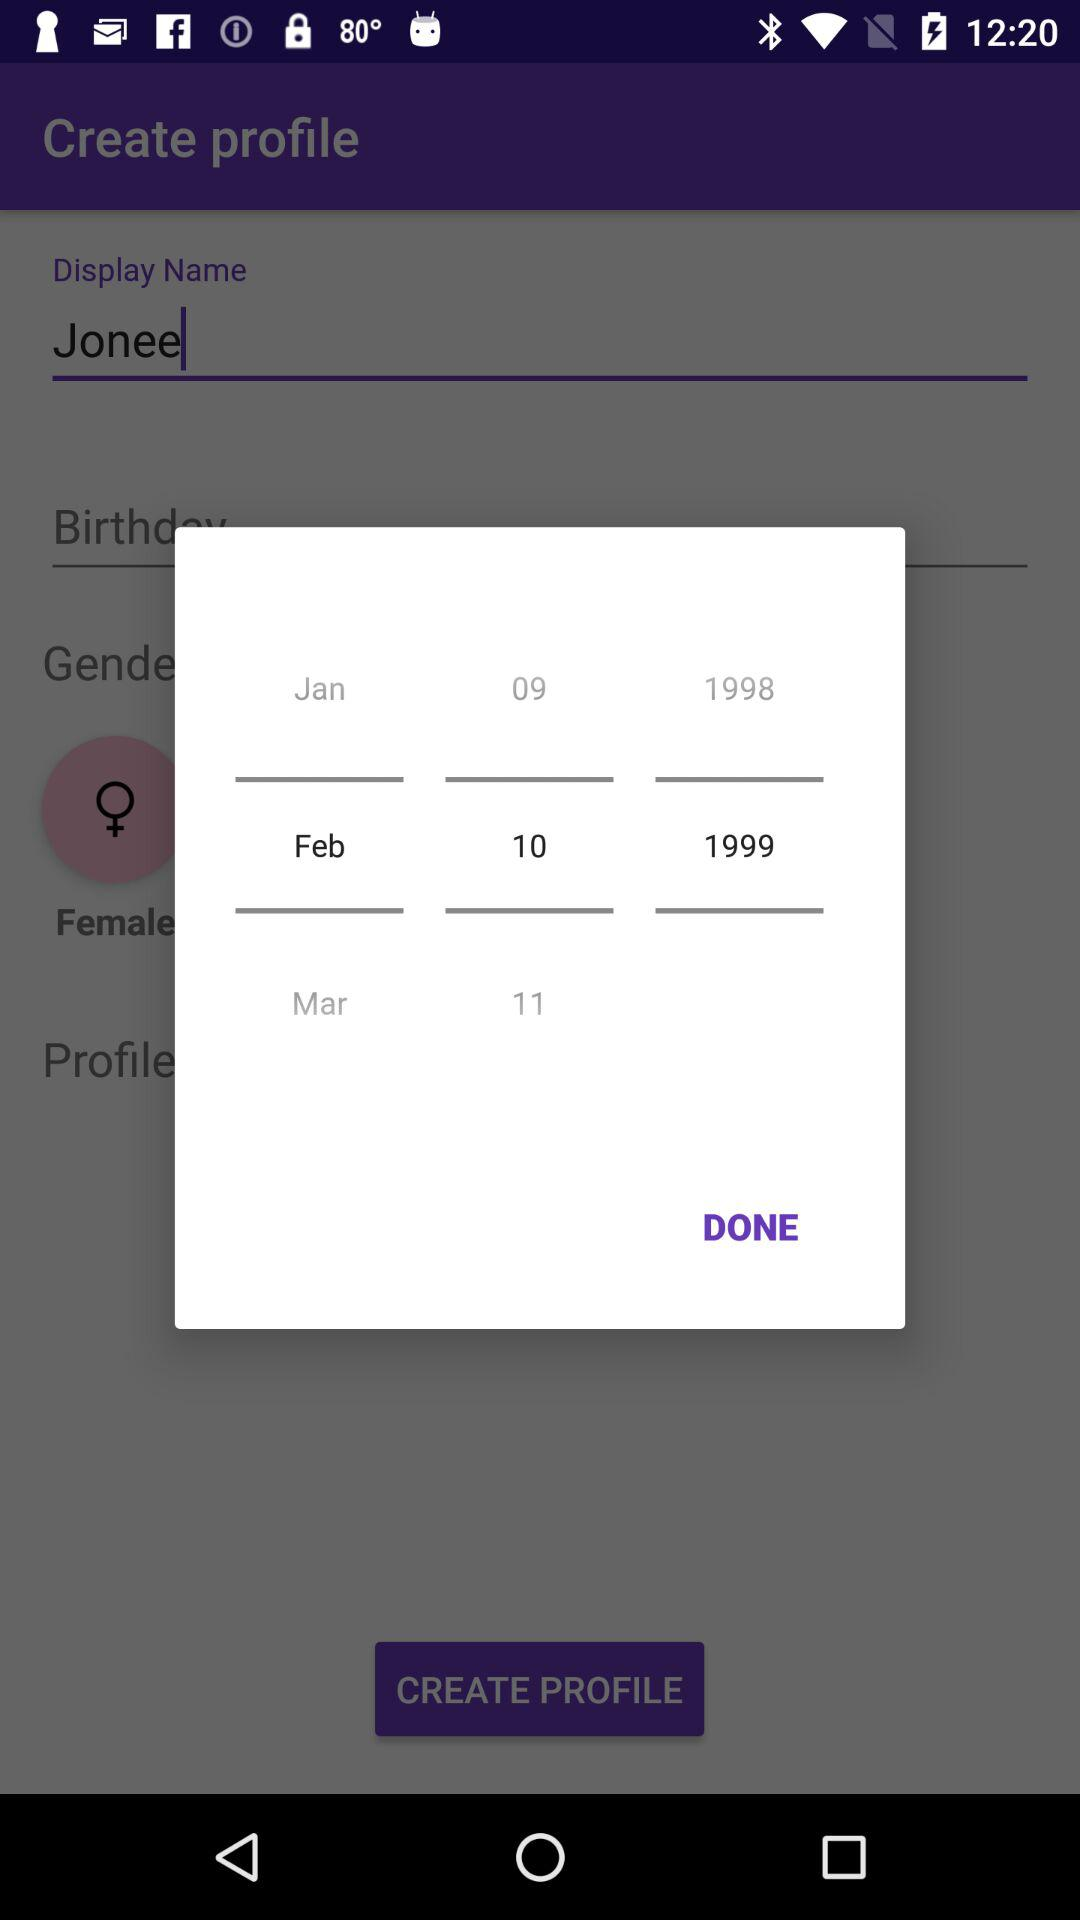Which date was selected? The selected date was February 10, 1999. 